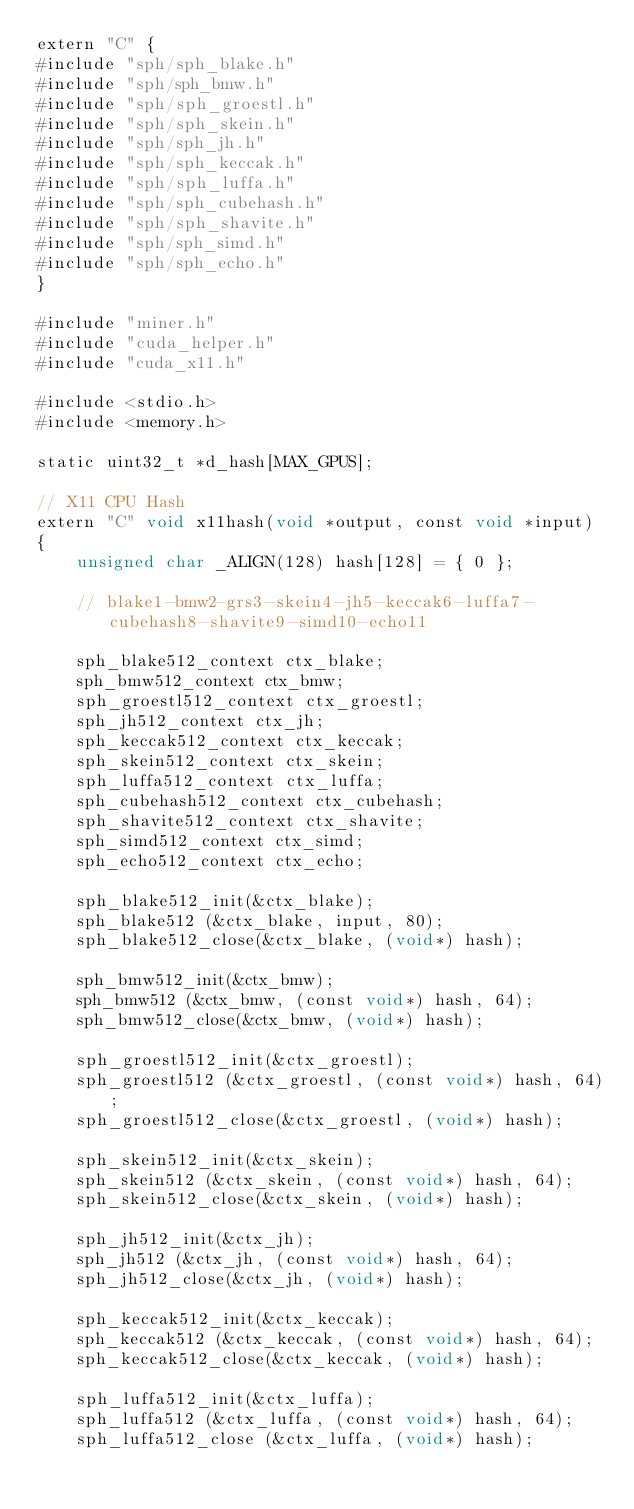Convert code to text. <code><loc_0><loc_0><loc_500><loc_500><_Cuda_>extern "C" {
#include "sph/sph_blake.h"
#include "sph/sph_bmw.h"
#include "sph/sph_groestl.h"
#include "sph/sph_skein.h"
#include "sph/sph_jh.h"
#include "sph/sph_keccak.h"
#include "sph/sph_luffa.h"
#include "sph/sph_cubehash.h"
#include "sph/sph_shavite.h"
#include "sph/sph_simd.h"
#include "sph/sph_echo.h"
}

#include "miner.h"
#include "cuda_helper.h"
#include "cuda_x11.h"

#include <stdio.h>
#include <memory.h>

static uint32_t *d_hash[MAX_GPUS];

// X11 CPU Hash
extern "C" void x11hash(void *output, const void *input)
{
	unsigned char _ALIGN(128) hash[128] = { 0 };

	// blake1-bmw2-grs3-skein4-jh5-keccak6-luffa7-cubehash8-shavite9-simd10-echo11

	sph_blake512_context ctx_blake;
	sph_bmw512_context ctx_bmw;
	sph_groestl512_context ctx_groestl;
	sph_jh512_context ctx_jh;
	sph_keccak512_context ctx_keccak;
	sph_skein512_context ctx_skein;
	sph_luffa512_context ctx_luffa;
	sph_cubehash512_context ctx_cubehash;
	sph_shavite512_context ctx_shavite;
	sph_simd512_context ctx_simd;
	sph_echo512_context ctx_echo;

	sph_blake512_init(&ctx_blake);
	sph_blake512 (&ctx_blake, input, 80);
	sph_blake512_close(&ctx_blake, (void*) hash);

	sph_bmw512_init(&ctx_bmw);
	sph_bmw512 (&ctx_bmw, (const void*) hash, 64);
	sph_bmw512_close(&ctx_bmw, (void*) hash);

	sph_groestl512_init(&ctx_groestl);
	sph_groestl512 (&ctx_groestl, (const void*) hash, 64);
	sph_groestl512_close(&ctx_groestl, (void*) hash);

	sph_skein512_init(&ctx_skein);
	sph_skein512 (&ctx_skein, (const void*) hash, 64);
	sph_skein512_close(&ctx_skein, (void*) hash);

	sph_jh512_init(&ctx_jh);
	sph_jh512 (&ctx_jh, (const void*) hash, 64);
	sph_jh512_close(&ctx_jh, (void*) hash);

	sph_keccak512_init(&ctx_keccak);
	sph_keccak512 (&ctx_keccak, (const void*) hash, 64);
	sph_keccak512_close(&ctx_keccak, (void*) hash);

	sph_luffa512_init(&ctx_luffa);
	sph_luffa512 (&ctx_luffa, (const void*) hash, 64);
	sph_luffa512_close (&ctx_luffa, (void*) hash);
</code> 